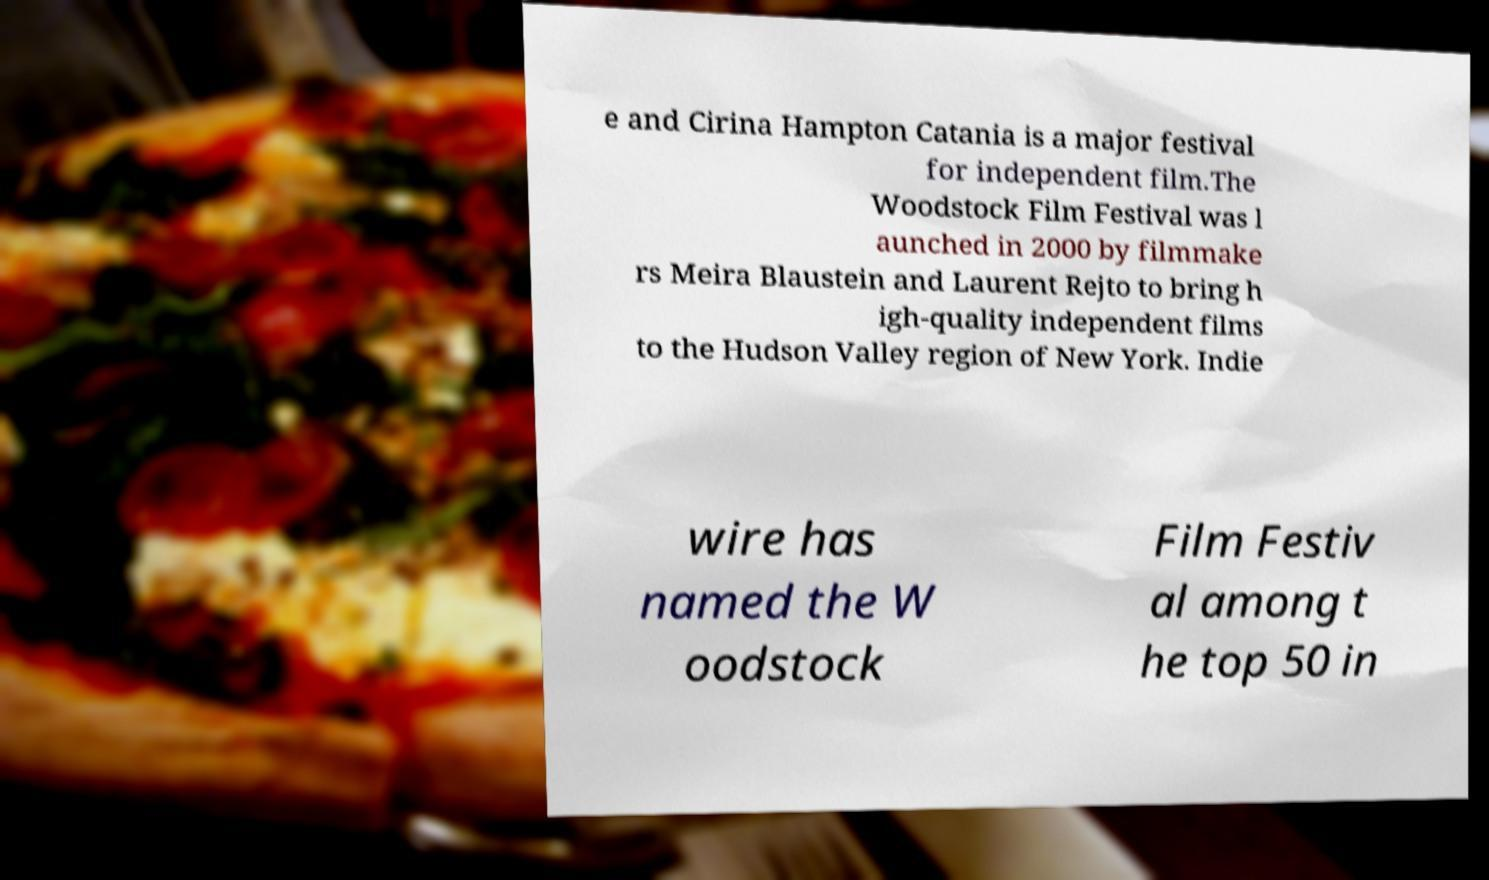Please identify and transcribe the text found in this image. e and Cirina Hampton Catania is a major festival for independent film.The Woodstock Film Festival was l aunched in 2000 by filmmake rs Meira Blaustein and Laurent Rejto to bring h igh-quality independent films to the Hudson Valley region of New York. Indie wire has named the W oodstock Film Festiv al among t he top 50 in 